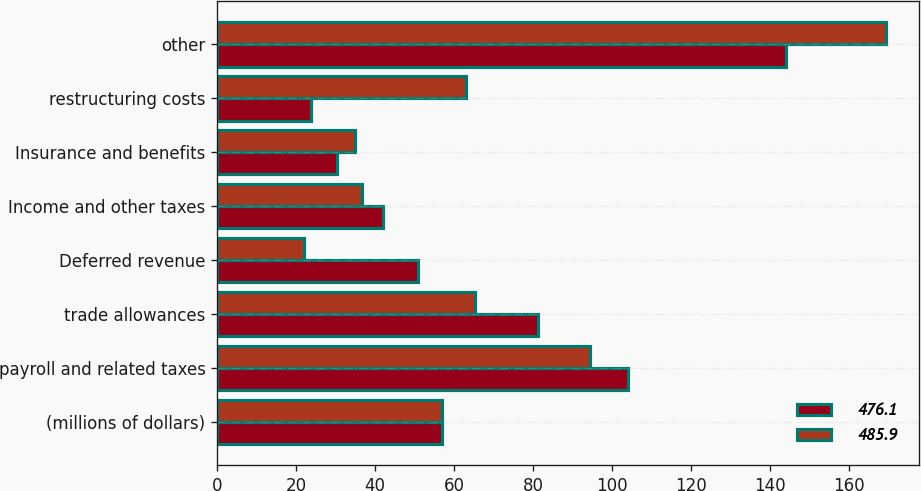Convert chart. <chart><loc_0><loc_0><loc_500><loc_500><stacked_bar_chart><ecel><fcel>(millions of dollars)<fcel>payroll and related taxes<fcel>trade allowances<fcel>Deferred revenue<fcel>Income and other taxes<fcel>Insurance and benefits<fcel>restructuring costs<fcel>other<nl><fcel>476.1<fcel>56.95<fcel>104<fcel>81.2<fcel>50.8<fcel>42.1<fcel>30.3<fcel>23.7<fcel>144<nl><fcel>485.9<fcel>56.95<fcel>94.5<fcel>65.4<fcel>21.9<fcel>36.7<fcel>35<fcel>63.1<fcel>169.3<nl></chart> 